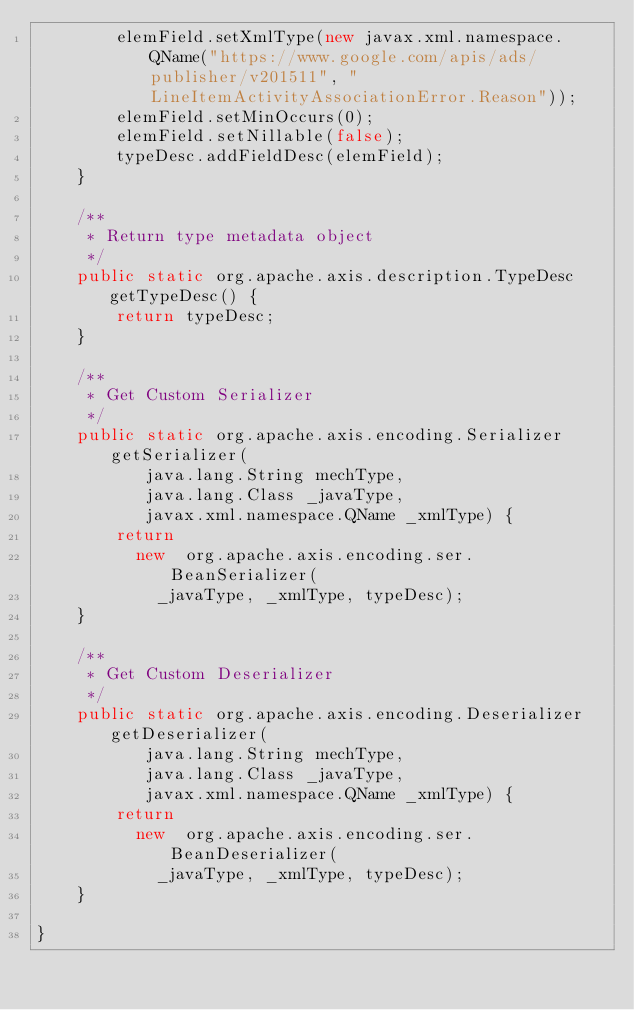<code> <loc_0><loc_0><loc_500><loc_500><_Java_>        elemField.setXmlType(new javax.xml.namespace.QName("https://www.google.com/apis/ads/publisher/v201511", "LineItemActivityAssociationError.Reason"));
        elemField.setMinOccurs(0);
        elemField.setNillable(false);
        typeDesc.addFieldDesc(elemField);
    }

    /**
     * Return type metadata object
     */
    public static org.apache.axis.description.TypeDesc getTypeDesc() {
        return typeDesc;
    }

    /**
     * Get Custom Serializer
     */
    public static org.apache.axis.encoding.Serializer getSerializer(
           java.lang.String mechType, 
           java.lang.Class _javaType,  
           javax.xml.namespace.QName _xmlType) {
        return 
          new  org.apache.axis.encoding.ser.BeanSerializer(
            _javaType, _xmlType, typeDesc);
    }

    /**
     * Get Custom Deserializer
     */
    public static org.apache.axis.encoding.Deserializer getDeserializer(
           java.lang.String mechType, 
           java.lang.Class _javaType,  
           javax.xml.namespace.QName _xmlType) {
        return 
          new  org.apache.axis.encoding.ser.BeanDeserializer(
            _javaType, _xmlType, typeDesc);
    }

}
</code> 